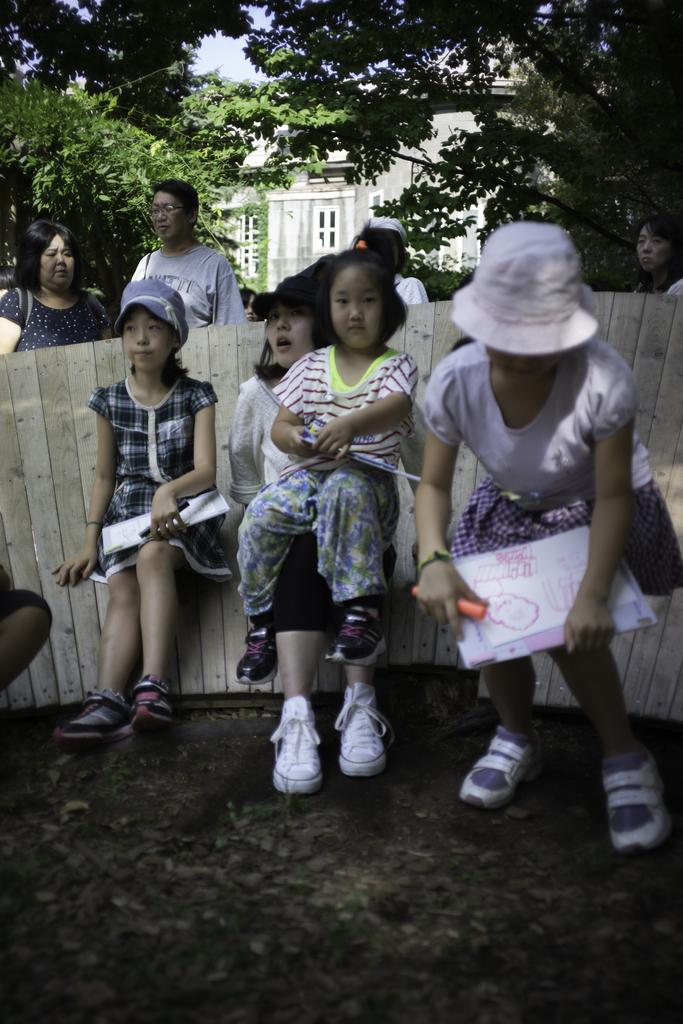How many people are in the group that is visible in the image? There is a group of people in the image, but the exact number is not specified. What are some people in the group wearing? Some people in the group are wearing caps. What can be seen in the background of the image? There are trees and a building in the background of the image. What type of society is depicted in the wilderness in the image? There is no depiction of a society or wilderness in the image; it features a group of people and a background with trees and a building. 